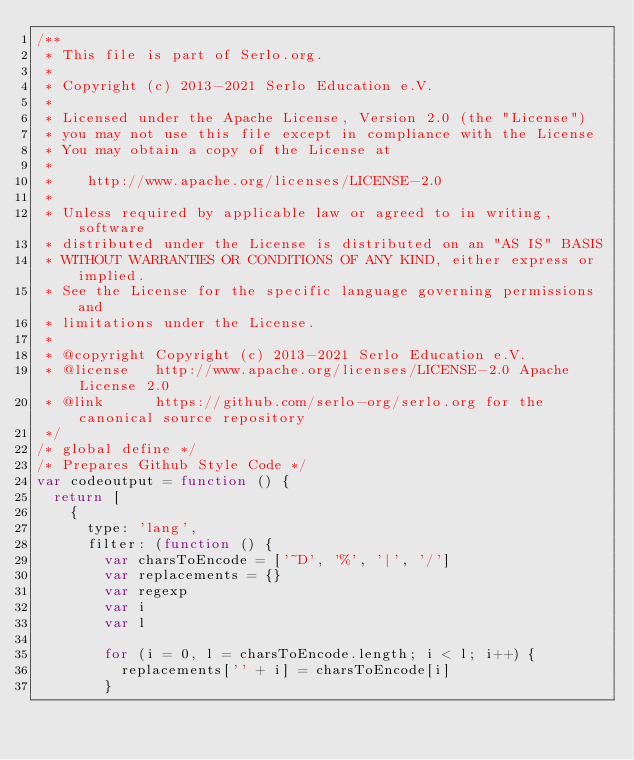<code> <loc_0><loc_0><loc_500><loc_500><_JavaScript_>/**
 * This file is part of Serlo.org.
 *
 * Copyright (c) 2013-2021 Serlo Education e.V.
 *
 * Licensed under the Apache License, Version 2.0 (the "License")
 * you may not use this file except in compliance with the License
 * You may obtain a copy of the License at
 *
 *    http://www.apache.org/licenses/LICENSE-2.0
 *
 * Unless required by applicable law or agreed to in writing, software
 * distributed under the License is distributed on an "AS IS" BASIS
 * WITHOUT WARRANTIES OR CONDITIONS OF ANY KIND, either express or implied.
 * See the License for the specific language governing permissions and
 * limitations under the License.
 *
 * @copyright Copyright (c) 2013-2021 Serlo Education e.V.
 * @license   http://www.apache.org/licenses/LICENSE-2.0 Apache License 2.0
 * @link      https://github.com/serlo-org/serlo.org for the canonical source repository
 */
/* global define */
/* Prepares Github Style Code */
var codeoutput = function () {
  return [
    {
      type: 'lang',
      filter: (function () {
        var charsToEncode = ['~D', '%', '|', '/']
        var replacements = {}
        var regexp
        var i
        var l

        for (i = 0, l = charsToEncode.length; i < l; i++) {
          replacements['' + i] = charsToEncode[i]
        }
</code> 